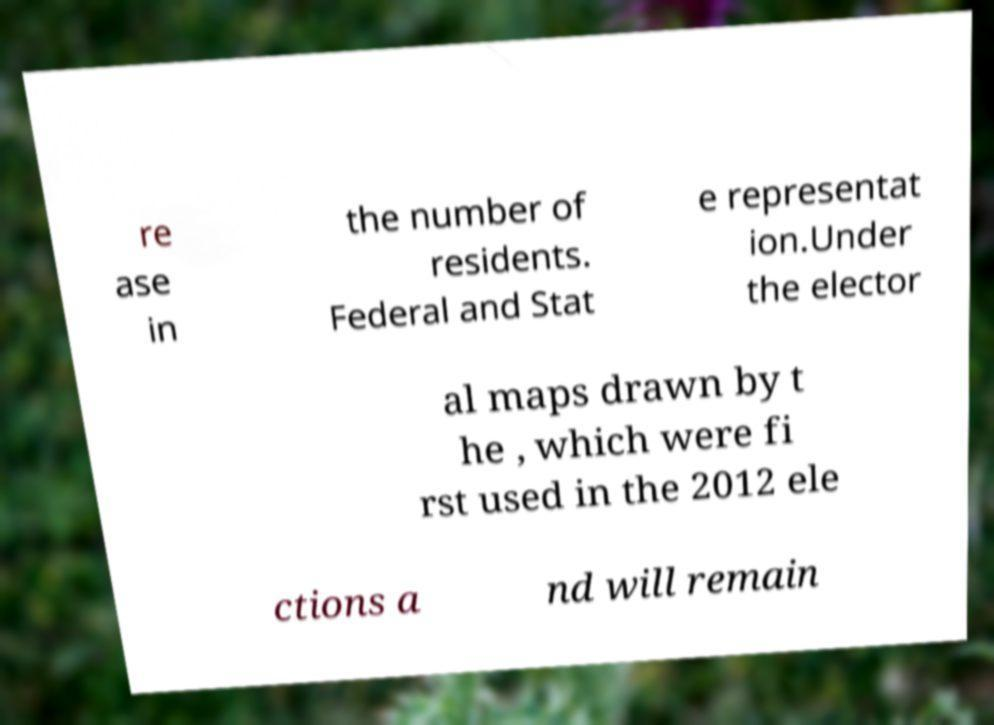What messages or text are displayed in this image? I need them in a readable, typed format. re ase in the number of residents. Federal and Stat e representat ion.Under the elector al maps drawn by t he , which were fi rst used in the 2012 ele ctions a nd will remain 